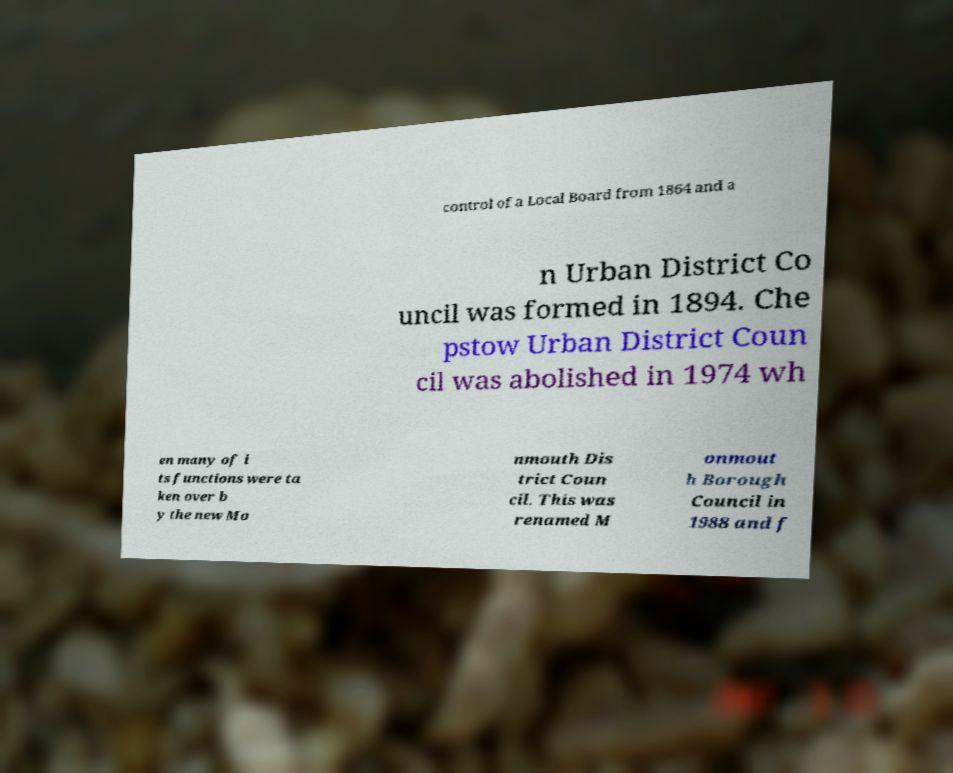Please read and relay the text visible in this image. What does it say? control of a Local Board from 1864 and a n Urban District Co uncil was formed in 1894. Che pstow Urban District Coun cil was abolished in 1974 wh en many of i ts functions were ta ken over b y the new Mo nmouth Dis trict Coun cil. This was renamed M onmout h Borough Council in 1988 and f 